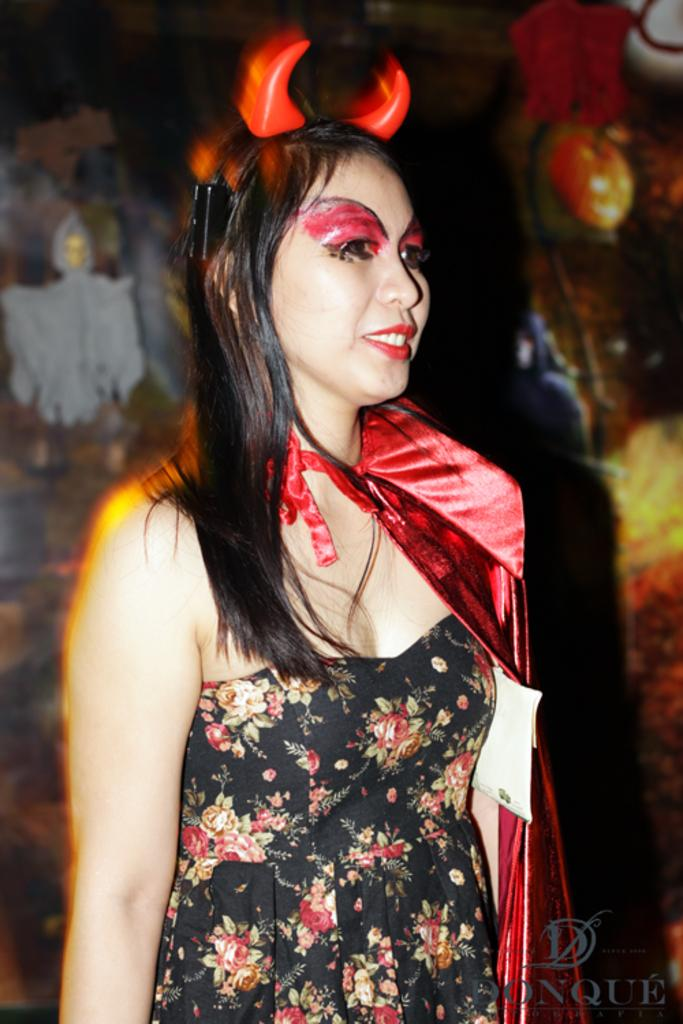Who is present in the image? There is a woman in the image. What is the woman doing in the image? The woman is standing in the image. What is the woman's facial expression? The woman is smiling in the image. What is on the woman's head? The woman is wearing devil horns on her head. Where is the text located in the image? There is some text at the right bottom of the image. We start by identifying the main subject in the image, which is the woman. Then, we expand the conversation to include her actions, facial expression, and the accessory she is wearing. Finally, we mention the presence of text in the image. What type of sweater is the woman wearing in the image? The woman is not wearing a sweater in the image; she is wearing devil horns on her head. 